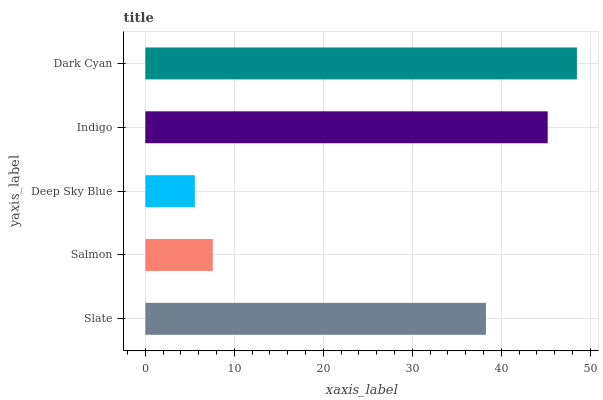Is Deep Sky Blue the minimum?
Answer yes or no. Yes. Is Dark Cyan the maximum?
Answer yes or no. Yes. Is Salmon the minimum?
Answer yes or no. No. Is Salmon the maximum?
Answer yes or no. No. Is Slate greater than Salmon?
Answer yes or no. Yes. Is Salmon less than Slate?
Answer yes or no. Yes. Is Salmon greater than Slate?
Answer yes or no. No. Is Slate less than Salmon?
Answer yes or no. No. Is Slate the high median?
Answer yes or no. Yes. Is Slate the low median?
Answer yes or no. Yes. Is Deep Sky Blue the high median?
Answer yes or no. No. Is Salmon the low median?
Answer yes or no. No. 